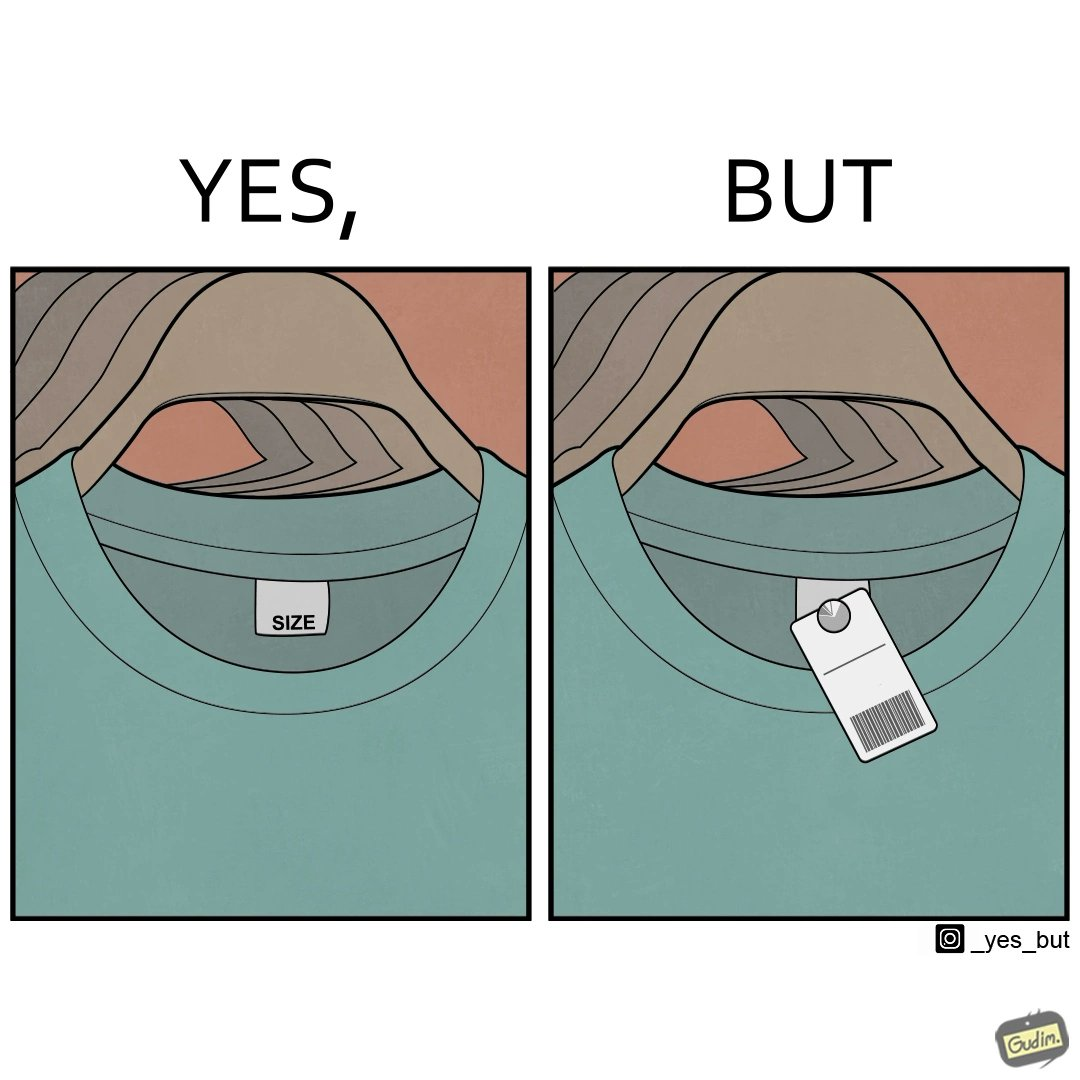What does this image depict? The image is ironic, because it shows over modernization, earlier the size was printed on the label attached to the clothes but now for knowing even the basic details about the cloth like size there is some barcode or QR code attached which need to be scanned by some mobile phone or electronic device 